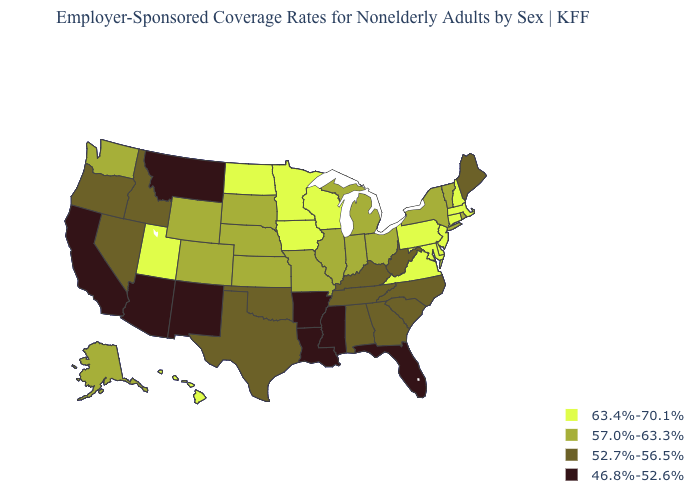Among the states that border Oklahoma , which have the highest value?
Give a very brief answer. Colorado, Kansas, Missouri. Does California have the lowest value in the USA?
Quick response, please. Yes. Is the legend a continuous bar?
Quick response, please. No. What is the lowest value in the MidWest?
Short answer required. 57.0%-63.3%. Does the first symbol in the legend represent the smallest category?
Short answer required. No. Does Utah have a higher value than New Hampshire?
Be succinct. No. Does New Mexico have the lowest value in the USA?
Short answer required. Yes. What is the lowest value in states that border Louisiana?
Be succinct. 46.8%-52.6%. Name the states that have a value in the range 63.4%-70.1%?
Short answer required. Connecticut, Delaware, Hawaii, Iowa, Maryland, Massachusetts, Minnesota, New Hampshire, New Jersey, North Dakota, Pennsylvania, Utah, Virginia, Wisconsin. Name the states that have a value in the range 46.8%-52.6%?
Short answer required. Arizona, Arkansas, California, Florida, Louisiana, Mississippi, Montana, New Mexico. What is the value of Iowa?
Be succinct. 63.4%-70.1%. What is the value of South Carolina?
Write a very short answer. 52.7%-56.5%. Name the states that have a value in the range 57.0%-63.3%?
Answer briefly. Alaska, Colorado, Illinois, Indiana, Kansas, Michigan, Missouri, Nebraska, New York, Ohio, Rhode Island, South Dakota, Vermont, Washington, Wyoming. Name the states that have a value in the range 46.8%-52.6%?
Be succinct. Arizona, Arkansas, California, Florida, Louisiana, Mississippi, Montana, New Mexico. Does North Dakota have the same value as California?
Write a very short answer. No. 